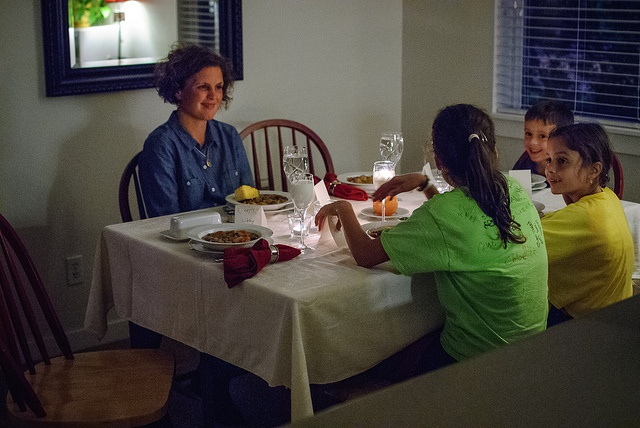Describe the objects in this image and their specific colors. I can see dining table in darkgreen, black, and gray tones, people in darkgreen, black, and maroon tones, chair in black and darkgreen tones, people in darkgreen, black, olive, and maroon tones, and people in darkgreen, black, navy, maroon, and brown tones in this image. 